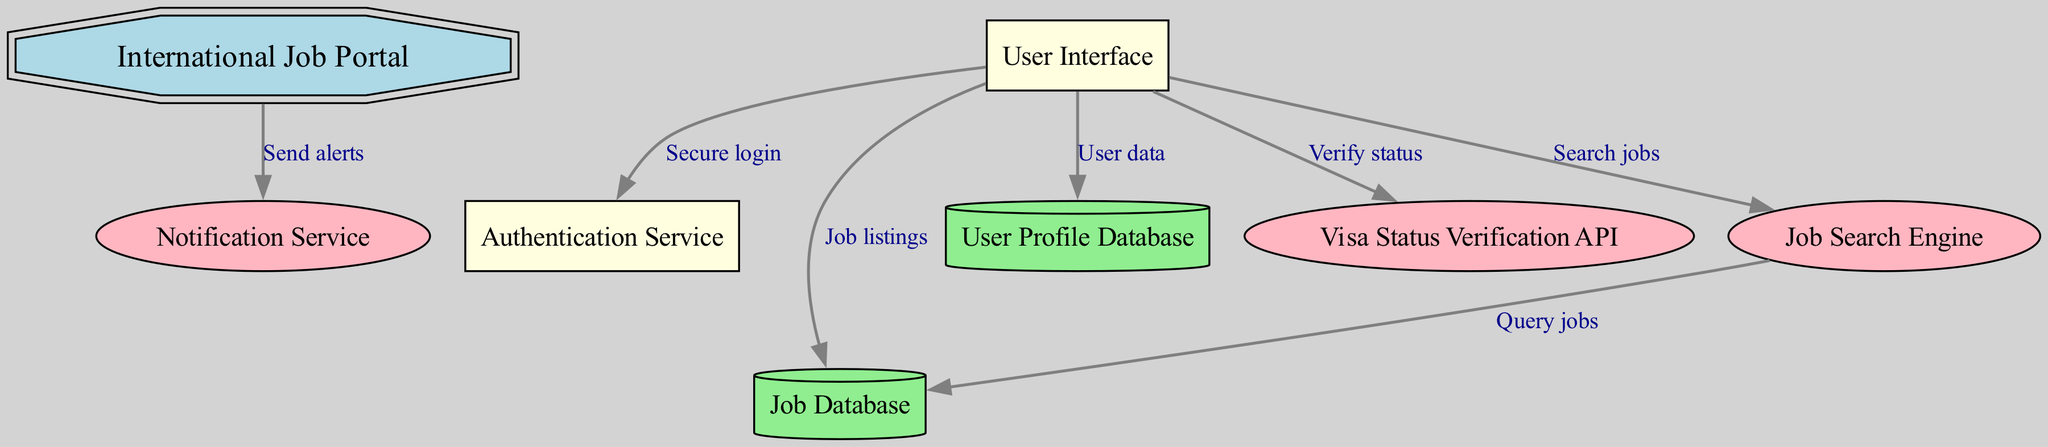What is the main component of the system architecture? The main component of the system architecture is represented by the node labeled "International Job Portal," which is the central element in the diagram.
Answer: International Job Portal How many databases are present in the diagram? The diagram shows two distinct databases: "Job Database" and "User Profile Database." Therefore, the total count is two.
Answer: 2 What type of service is the "Visa Status Verification API"? The "Visa Status Verification API" is indicated as an ellipse in the diagram, which typically denotes a service or a process.
Answer: Service What connects the "User Interface" to the "Job Database"? The link connecting "User Interface" to "Job Database" is labeled "Job listings," which indicates the nature of this connection.
Answer: Job listings Which node sends alerts through notifications? The "International Job Portal" node is connected to the "Notification Service" node, signifying that it is responsible for sending alerts.
Answer: International Job Portal What action does the "Search Engine" perform on the "Job Database"? The edge from the "Search Engine" to the "Job Database" is labeled "Query jobs," indicating that this is the action performed.
Answer: Query jobs Which component allows users to securely log in? The edge labeled "Secure login" between "User Interface" and "Authentication Service" confirms this function is performed by the Authentication Service.
Answer: Authentication Service Which kind of data does the "User Interface" connect to in the "User Profile Database"? The connection is labeled "User data," showing that the User Interface interacts with user-related information stored in the User Profile Database.
Answer: User data How many total edges are there in the diagram? By counting the edges connecting the nodes, there are a total of six edges shown in the diagram.
Answer: 6 